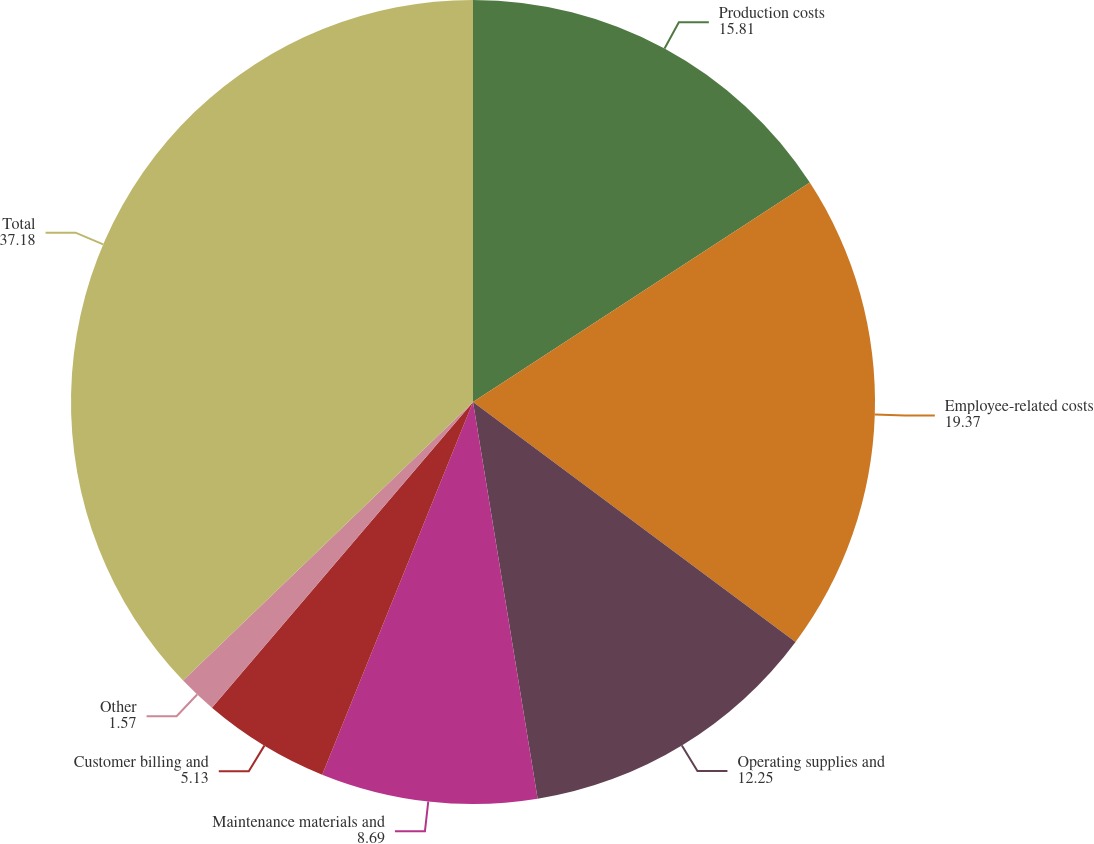<chart> <loc_0><loc_0><loc_500><loc_500><pie_chart><fcel>Production costs<fcel>Employee-related costs<fcel>Operating supplies and<fcel>Maintenance materials and<fcel>Customer billing and<fcel>Other<fcel>Total<nl><fcel>15.81%<fcel>19.37%<fcel>12.25%<fcel>8.69%<fcel>5.13%<fcel>1.57%<fcel>37.18%<nl></chart> 